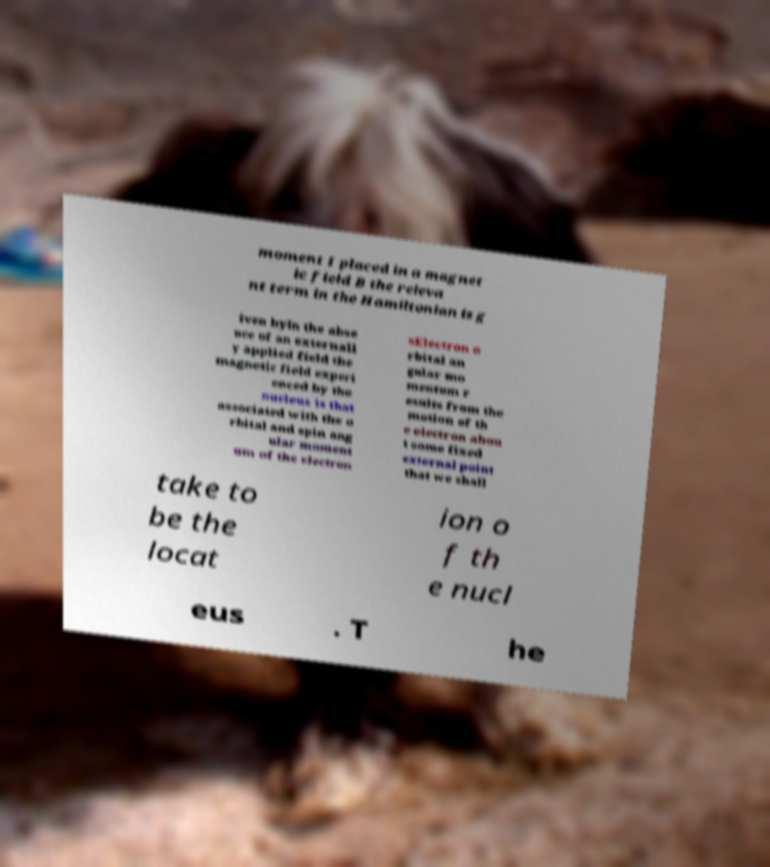Can you accurately transcribe the text from the provided image for me? moment I placed in a magnet ic field B the releva nt term in the Hamiltonian is g iven byIn the abse nce of an externall y applied field the magnetic field experi enced by the nucleus is that associated with the o rbital and spin ang ular moment um of the electron sElectron o rbital an gular mo mentum r esults from the motion of th e electron abou t some fixed external point that we shall take to be the locat ion o f th e nucl eus . T he 